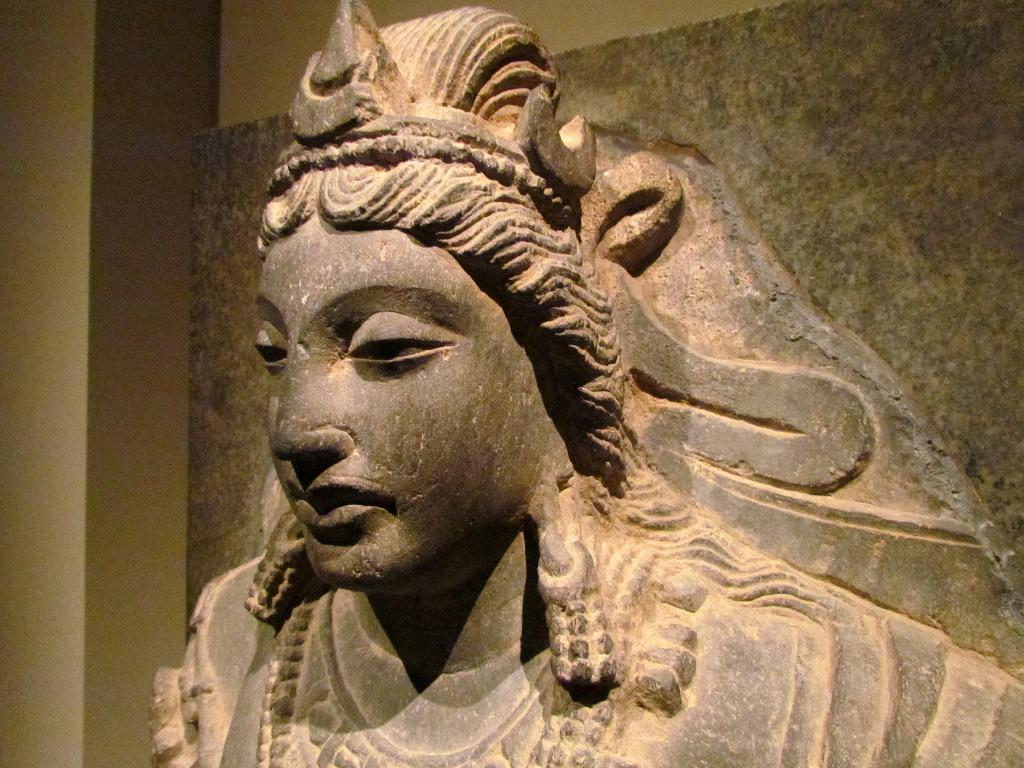What is on the wall in the image? There is a sculpture on the wall in the image. What can be seen on the left side of the image? There is a pillar on the left side of the image. How many corks are attached to the sculpted to the wall in the image? There is no mention of corks in the image; the wall features a sculpture. What type of car is parked next to the pillar in the image? There is no car present in the image; it only features a pillar and a sculpture on the wall. 